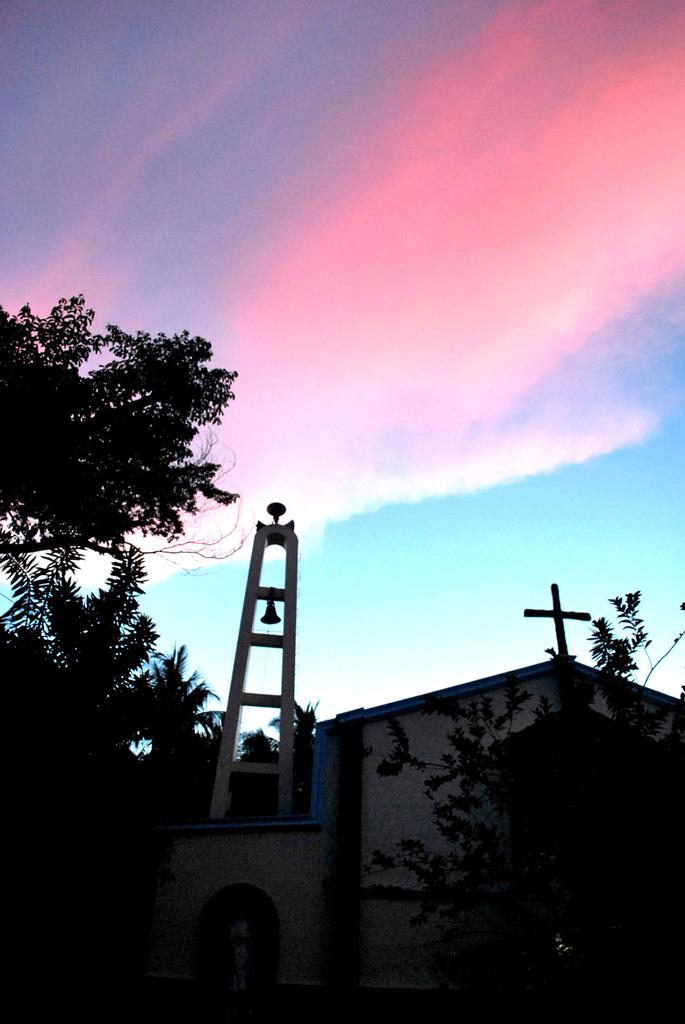What can be seen in the background of the image? The sky is visible in the background of the image. What type of building is in the image? There is a church in the image. What other natural elements are present in the image? There are trees in the image. What is a specific feature of the church in the image? A bell is present in the image. Can you describe the overall appearance of the image? The bottom portion of the image is completely dark. What type of pie is being served at the impulse in the image? There is no impulse or pie present in the image. Can you describe the wren's nest in the tree in the image? There is no wren or nest visible in the image; only trees are present. 